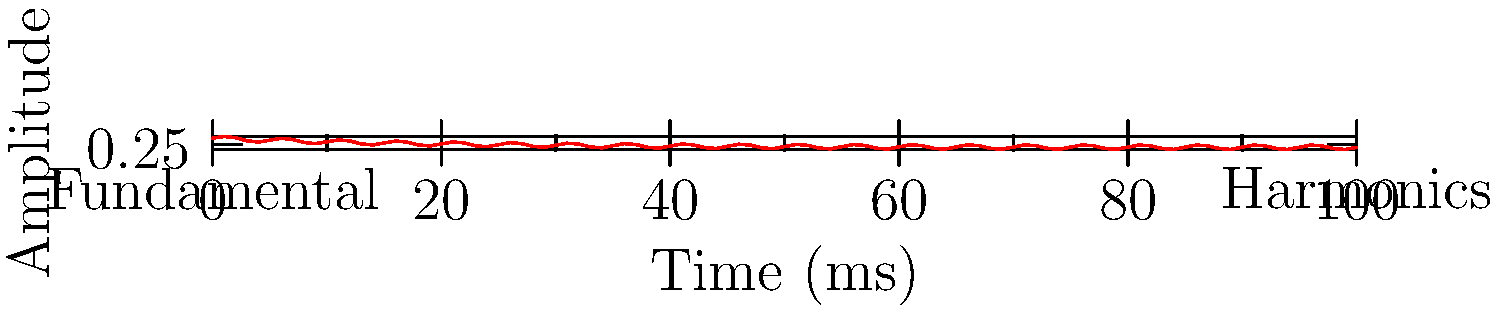Analyze the frequency spectrum shown in the graph, which represents a typical trap bassline. What characteristic feature of trap music does the combination of the fundamental frequency and harmonics create? To answer this question, let's break down the components of the graph and their significance in trap music:

1. Fundamental frequency: The graph shows a strong, decaying low-frequency component (red line starting high and decreasing). This represents the fundamental frequency of the bassline, which is crucial in trap music.

2. Harmonics: The oscillating pattern superimposed on the fundamental represents higher frequency harmonics. These add complexity and richness to the sound.

3. Decay: The overall decreasing amplitude over time indicates a quick decay, typical of trap basslines.

4. Combination effect: The interaction between the fundamental and harmonics creates a unique timbre characteristic of trap music.

5. "808" sound: This combination of a strong fundamental with quick decay and complex harmonics is often referred to as an "808" bass sound, named after the Roland TR-808 drum machine.

6. Sonic character: This spectral composition results in a deep, punchy bass sound that cuts through the mix while providing a full, rich low-end.

The key characteristic feature created by this combination is the distinctive "808-style" bass sound, which is a hallmark of trap music. It provides both the low-end foundation and a percussive element that drives the rhythm of trap tracks.
Answer: 808-style bass sound 